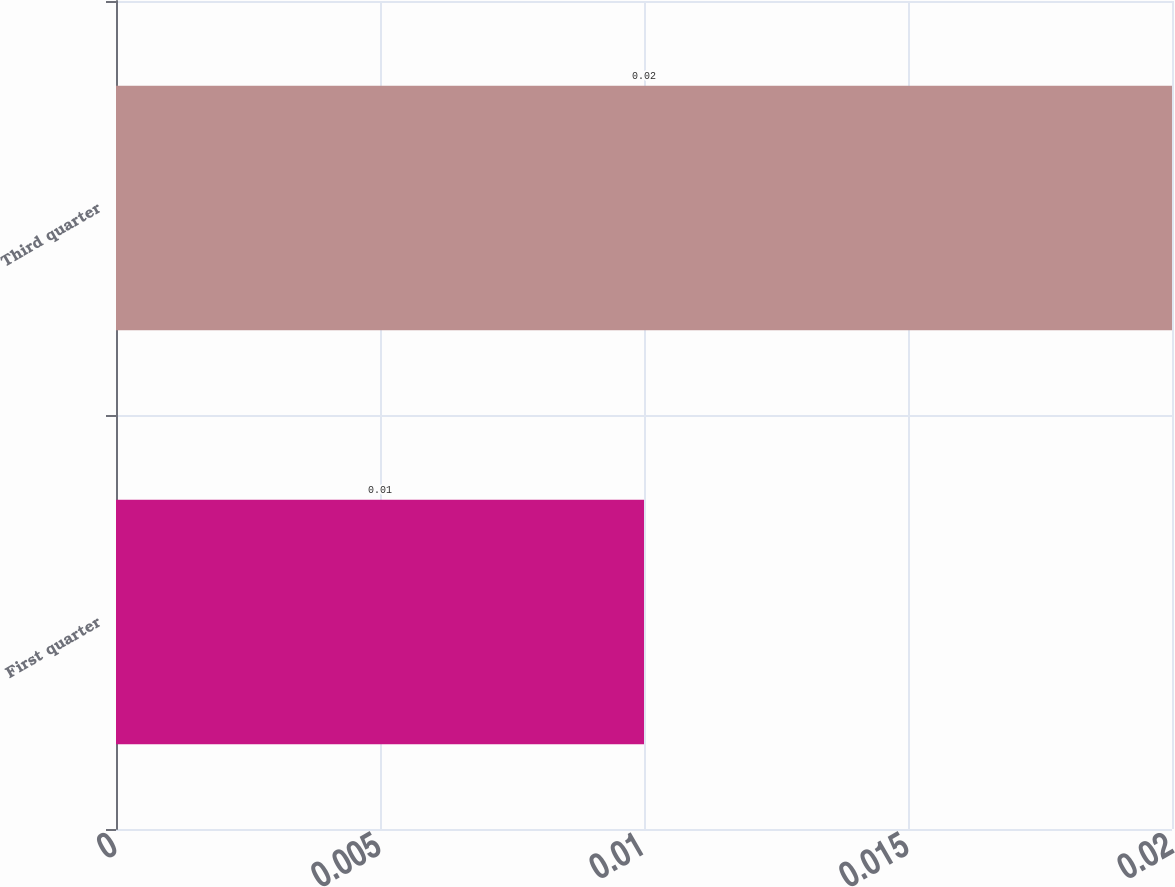<chart> <loc_0><loc_0><loc_500><loc_500><bar_chart><fcel>First quarter<fcel>Third quarter<nl><fcel>0.01<fcel>0.02<nl></chart> 